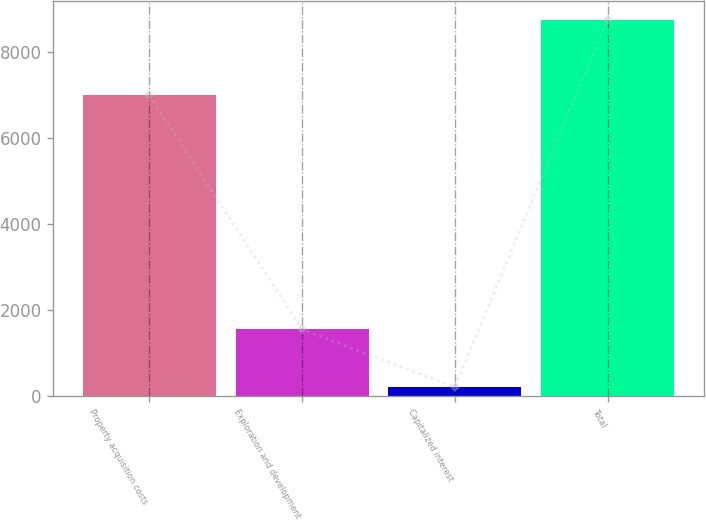Convert chart to OTSL. <chart><loc_0><loc_0><loc_500><loc_500><bar_chart><fcel>Property acquisition costs<fcel>Exploration and development<fcel>Capitalized interest<fcel>Total<nl><fcel>6998<fcel>1550<fcel>206<fcel>8754<nl></chart> 